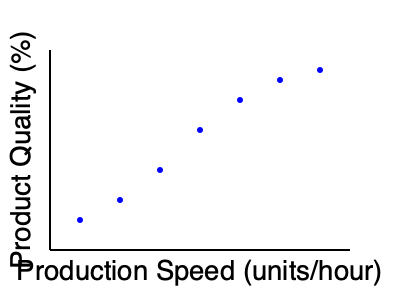Based on the scatter plot, what is the relationship between production speed and product quality? How would this information impact your decision-making as an operations manager? To interpret the scatter plot and its implications for an operations manager, let's follow these steps:

1. Observe the general trend:
   The data points show a clear downward trend from left to right.

2. Interpret the axes:
   x-axis: Production Speed (units/hour) - increases from left to right
   y-axis: Product Quality (%) - increases from bottom to top

3. Analyze the relationship:
   As production speed increases, product quality tends to decrease. This indicates a negative correlation between the two variables.

4. Quantify the relationship:
   The relationship appears to be non-linear, with quality dropping more rapidly at lower speeds and then leveling off somewhat at higher speeds.

5. Consider the implications for an operations manager:
   a) There's a trade-off between speed and quality.
   b) Increasing production speed will likely result in lower product quality.
   c) Decreasing production speed could improve product quality.

6. Decision-making impact:
   a) The manager must balance the need for high production volume with the desire for high-quality products.
   b) Optimal production speed might be found at a point where quality is acceptable while maintaining sufficient output.
   c) The manager may need to consider implementing quality control measures or process improvements to maintain quality at higher speeds.
   d) Different production speeds might be appropriate for different product lines or customer requirements.

7. Additional considerations:
   a) The manager should investigate the causes of quality decline at higher speeds.
   b) Cost-benefit analysis of speed vs. quality should be performed.
   c) Customer expectations and market positioning should be taken into account when setting production targets.
Answer: Negative correlation; balance speed and quality for optimal production 